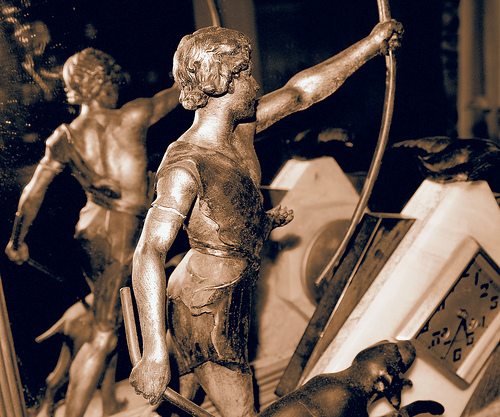<image>
Is the man on the dog? No. The man is not positioned on the dog. They may be near each other, but the man is not supported by or resting on top of the dog. 